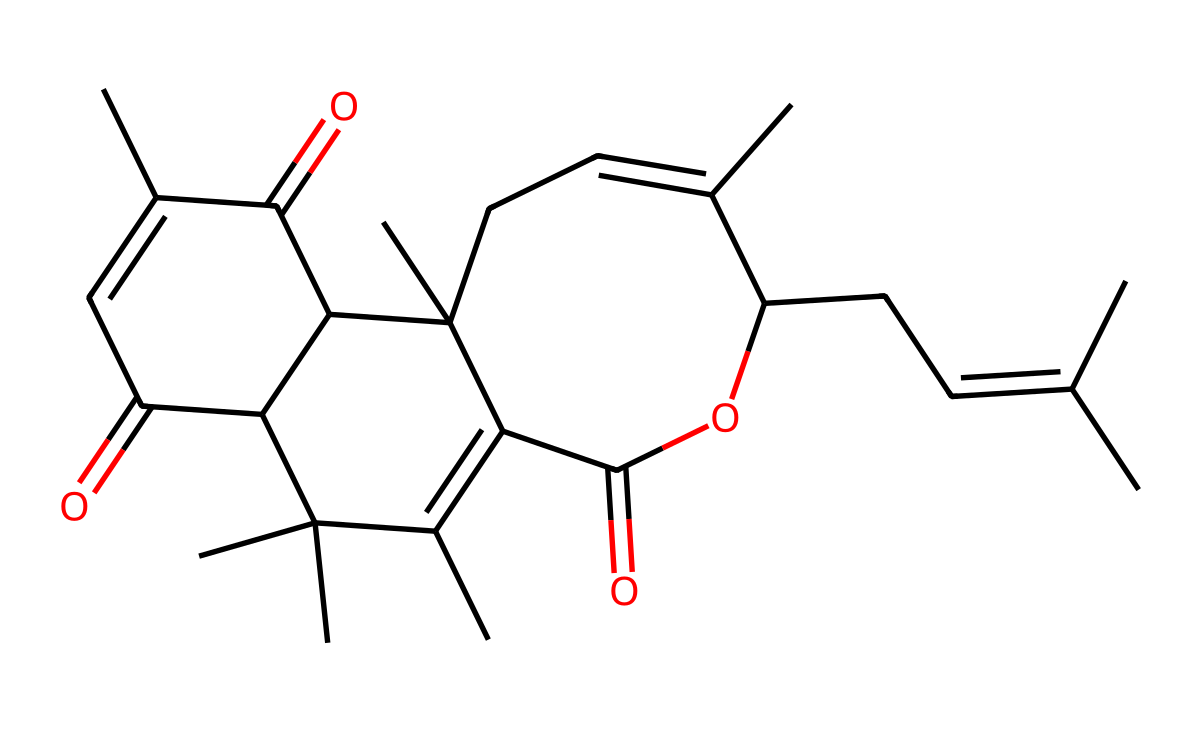What is the main functional group present in this molecule? The chemical structure shows a carbonyl (C=O) group, which is visible at several points in the molecule, indicating the presence of ketones and esters.
Answer: carbonyl How many rings are present in the molecular structure? By examining the SMILES representation, it is evident that there are three cyclic structures in the chemical, represented by the numbers in the SMILES that suggest cyclic connections.
Answer: three Is this chemical likely to be soluble in water? Considering that this molecule contains multiple carbon chains and rings with limited polar functional groups, it suggests a higher hydrophobic character, decreasing solubility in water.
Answer: no Does this molecule include any heteroatoms? The provided SMILES representation does not specify any heteroatoms, such as nitrogen, oxygen, or halogens, indicating that the structure comprises only carbon and hydrogen.
Answer: no What type of bond predominates in this molecular structure? Given the presence of C=C (double bonds) along with C=C, the molecule primarily demonstrates the characteristics of unsaturated bonds throughout its structure.
Answer: double What kind of isomerism might this molecule exhibit? The presence of double bonds in the structure suggests that it could potentially exhibit geometric (cis/trans) isomerism, depending on the arrangement of substituents around the double bonds.
Answer: geometric 